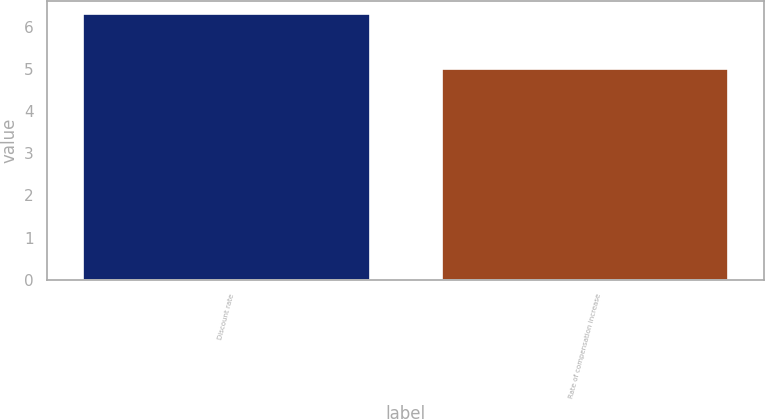Convert chart. <chart><loc_0><loc_0><loc_500><loc_500><bar_chart><fcel>Discount rate<fcel>Rate of compensation increase<nl><fcel>6.3<fcel>5<nl></chart> 